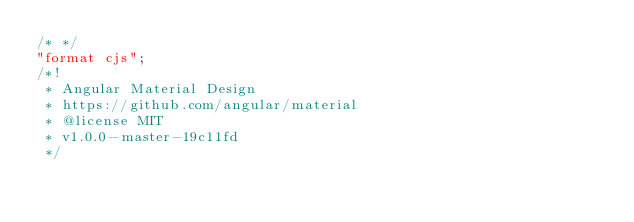<code> <loc_0><loc_0><loc_500><loc_500><_JavaScript_>/* */ 
"format cjs";
/*!
 * Angular Material Design
 * https://github.com/angular/material
 * @license MIT
 * v1.0.0-master-19c11fd
 */</code> 